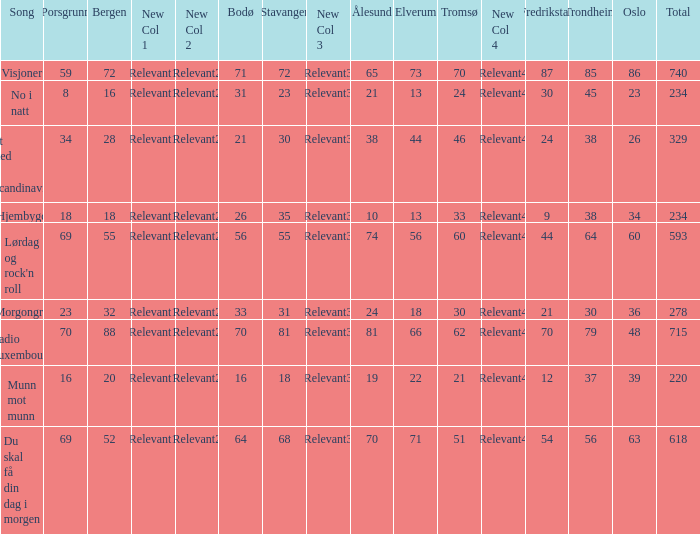What is the lowest total? 220.0. 